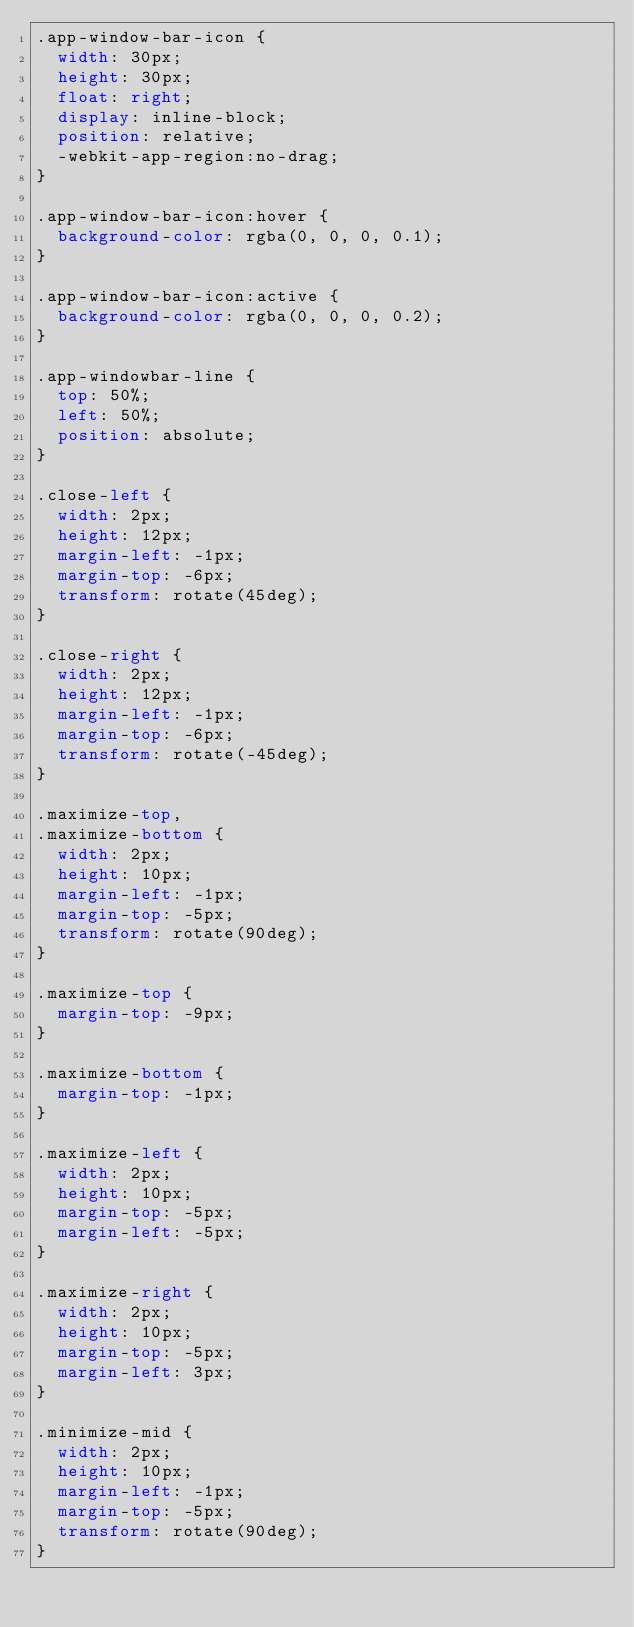Convert code to text. <code><loc_0><loc_0><loc_500><loc_500><_CSS_>.app-window-bar-icon {
  width: 30px;
  height: 30px;
  float: right;
  display: inline-block;
  position: relative;
  -webkit-app-region:no-drag;
}

.app-window-bar-icon:hover {
  background-color: rgba(0, 0, 0, 0.1);
}

.app-window-bar-icon:active {
  background-color: rgba(0, 0, 0, 0.2);
}

.app-windowbar-line {
  top: 50%;
  left: 50%;
  position: absolute;
}

.close-left {
  width: 2px;
  height: 12px;
  margin-left: -1px;
  margin-top: -6px;
  transform: rotate(45deg);
}

.close-right {
  width: 2px;
  height: 12px;
  margin-left: -1px;
  margin-top: -6px;
  transform: rotate(-45deg);
}

.maximize-top,
.maximize-bottom {
  width: 2px;
  height: 10px;
  margin-left: -1px;
  margin-top: -5px;
  transform: rotate(90deg);
}

.maximize-top {
  margin-top: -9px;
}

.maximize-bottom {
  margin-top: -1px;
}

.maximize-left {
  width: 2px;
  height: 10px;
  margin-top: -5px;
  margin-left: -5px;
}

.maximize-right {
  width: 2px;
  height: 10px;
  margin-top: -5px;
  margin-left: 3px;
}

.minimize-mid {
  width: 2px;
  height: 10px;
  margin-left: -1px;
  margin-top: -5px;
  transform: rotate(90deg);
}
</code> 